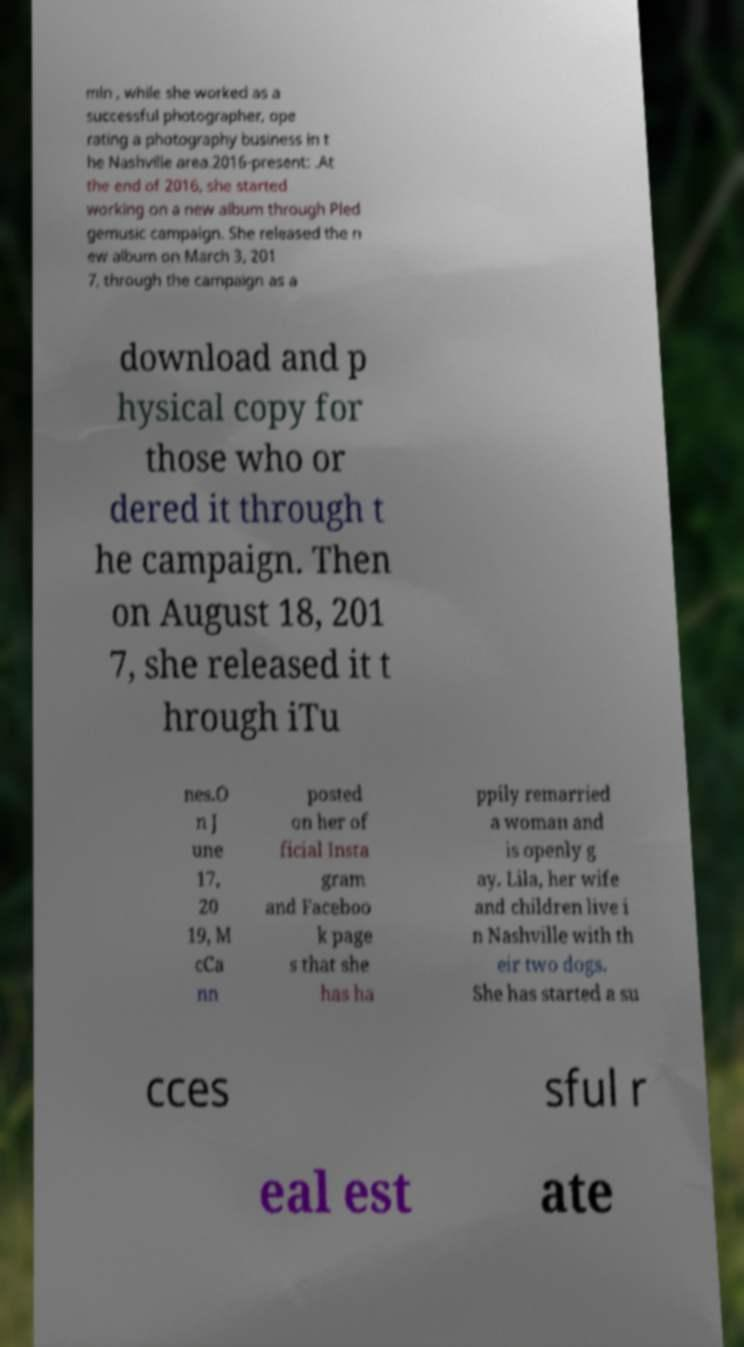What messages or text are displayed in this image? I need them in a readable, typed format. min , while she worked as a successful photographer, ope rating a photography business in t he Nashville area.2016-present: .At the end of 2016, she started working on a new album through Pled gemusic campaign. She released the n ew album on March 3, 201 7, through the campaign as a download and p hysical copy for those who or dered it through t he campaign. Then on August 18, 201 7, she released it t hrough iTu nes.O n J une 17, 20 19, M cCa nn posted on her of ficial Insta gram and Faceboo k page s that she has ha ppily remarried a woman and is openly g ay. Lila, her wife and children live i n Nashville with th eir two dogs. She has started a su cces sful r eal est ate 